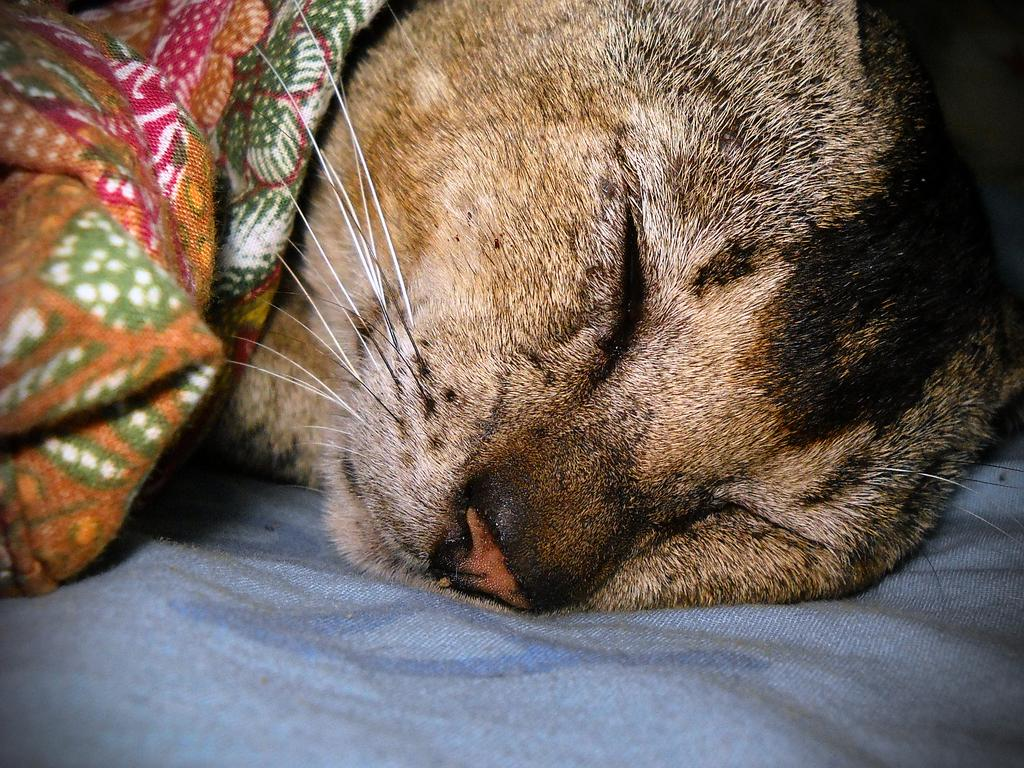What type of animal is in the image? There is a cat in the image. What is the cat doing in the image? The cat is sleeping. Where is the cat located in the image? The cat is on a bed-sheet. What is covering the cat in the image? There is a cloth on the cat. What type of hair can be seen on the cat in the image? There is no mention of the cat's hair in the provided facts, so it cannot be determined from the image. How many cakes are visible in the image? There are no cakes present in the image. 